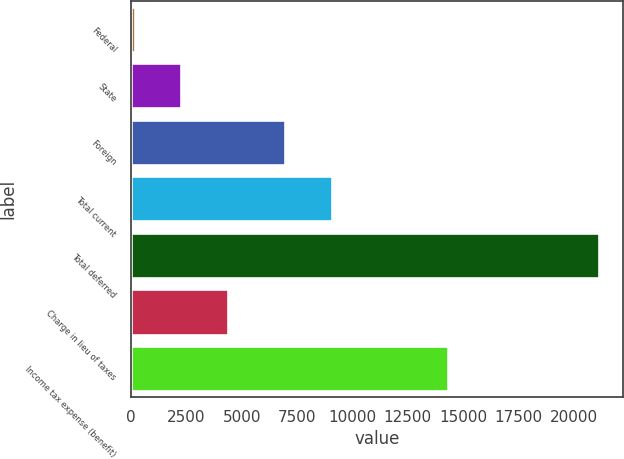Convert chart to OTSL. <chart><loc_0><loc_0><loc_500><loc_500><bar_chart><fcel>Federal<fcel>State<fcel>Foreign<fcel>Total current<fcel>Total deferred<fcel>Charge in lieu of taxes<fcel>Income tax expense (benefit)<nl><fcel>177<fcel>2274<fcel>6966<fcel>9063<fcel>21147<fcel>4371<fcel>14307<nl></chart> 